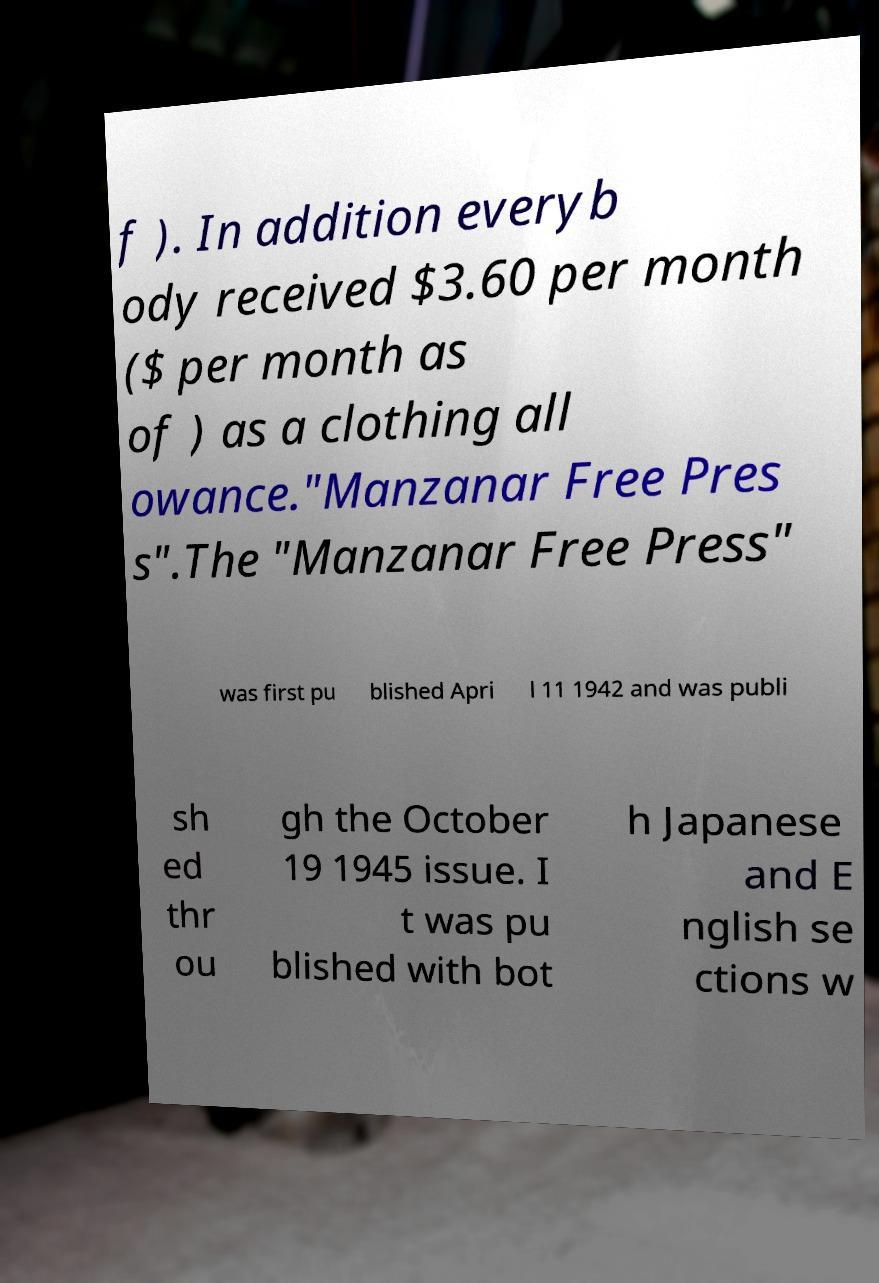For documentation purposes, I need the text within this image transcribed. Could you provide that? f ). In addition everyb ody received $3.60 per month ($ per month as of ) as a clothing all owance."Manzanar Free Pres s".The "Manzanar Free Press" was first pu blished Apri l 11 1942 and was publi sh ed thr ou gh the October 19 1945 issue. I t was pu blished with bot h Japanese and E nglish se ctions w 